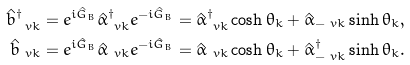Convert formula to latex. <formula><loc_0><loc_0><loc_500><loc_500>\hat { b } _ { \ v k } ^ { \dagger } & = e ^ { i \hat { G } _ { B } } \hat { \alpha } _ { \ v k } ^ { \dagger } e ^ { - i \hat { G } _ { B } } = \hat { \alpha } _ { \ v k } ^ { \dagger } \cosh \theta _ { k } + \hat { \alpha } _ { - \ v k } \sinh \theta _ { k } , \\ \hat { b } _ { \ v k } & = e ^ { i \hat { G } _ { B } } \hat { \alpha } _ { \ v k } e ^ { - i \hat { G } _ { B } } = \hat { \alpha } _ { \ v k } \cosh \theta _ { k } + \hat { \alpha } _ { - \ v k } ^ { \dagger } \sinh \theta _ { k } .</formula> 